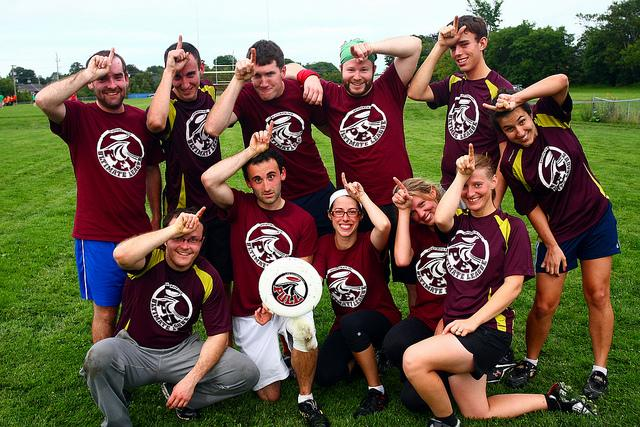What is the finger everyone is holding up commonly called? Please explain your reasoning. index finger. The finger next to their thumb. 